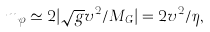Convert formula to latex. <formula><loc_0><loc_0><loc_500><loc_500>m _ { \varphi } \simeq 2 | \sqrt { g } v ^ { 2 } / M _ { G } | = 2 v ^ { 2 } / \eta ,</formula> 